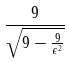<formula> <loc_0><loc_0><loc_500><loc_500>\frac { 9 } { \sqrt { 9 - \frac { 9 } { \epsilon ^ { 2 } } } }</formula> 